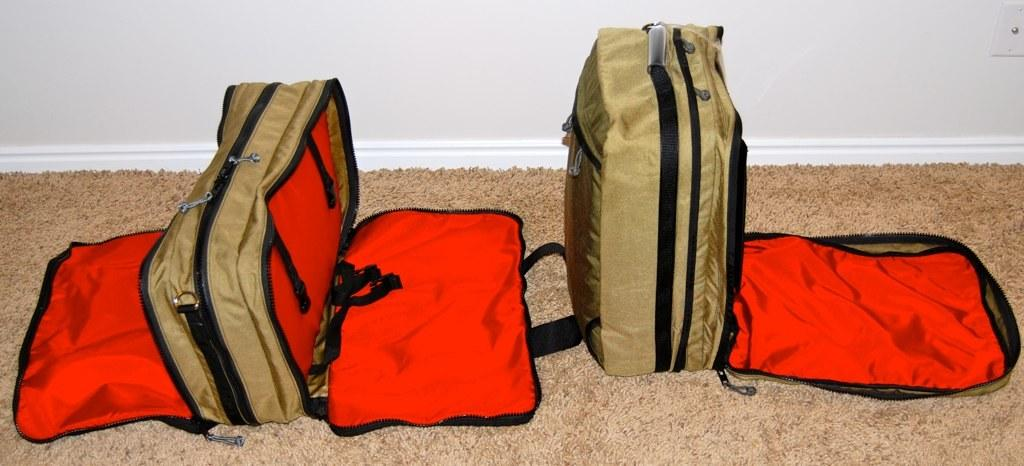What color are some of the luggage bags on the floor? There are brown and red luggage bags on the floor. Where are the luggage bags located in the image? The luggage bags are on the floor. What can be seen in the background of the image? There is a wall visible in the background. How many kittens are playing with the straw in the scene? There are no kittens or straw present in the image. 